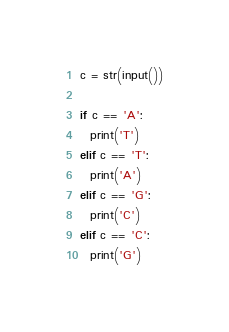<code> <loc_0><loc_0><loc_500><loc_500><_Python_>c = str(input())

if c == 'A':
  print('T')
elif c == 'T':
  print('A')
elif c == 'G':
  print('C')
elif c == 'C':
  print('G')
</code> 